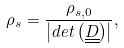Convert formula to latex. <formula><loc_0><loc_0><loc_500><loc_500>\rho _ { s } = \frac { \rho _ { s , 0 } } { \left | d e t \left ( \underline { \underline { D } } \right ) \right | } ,</formula> 